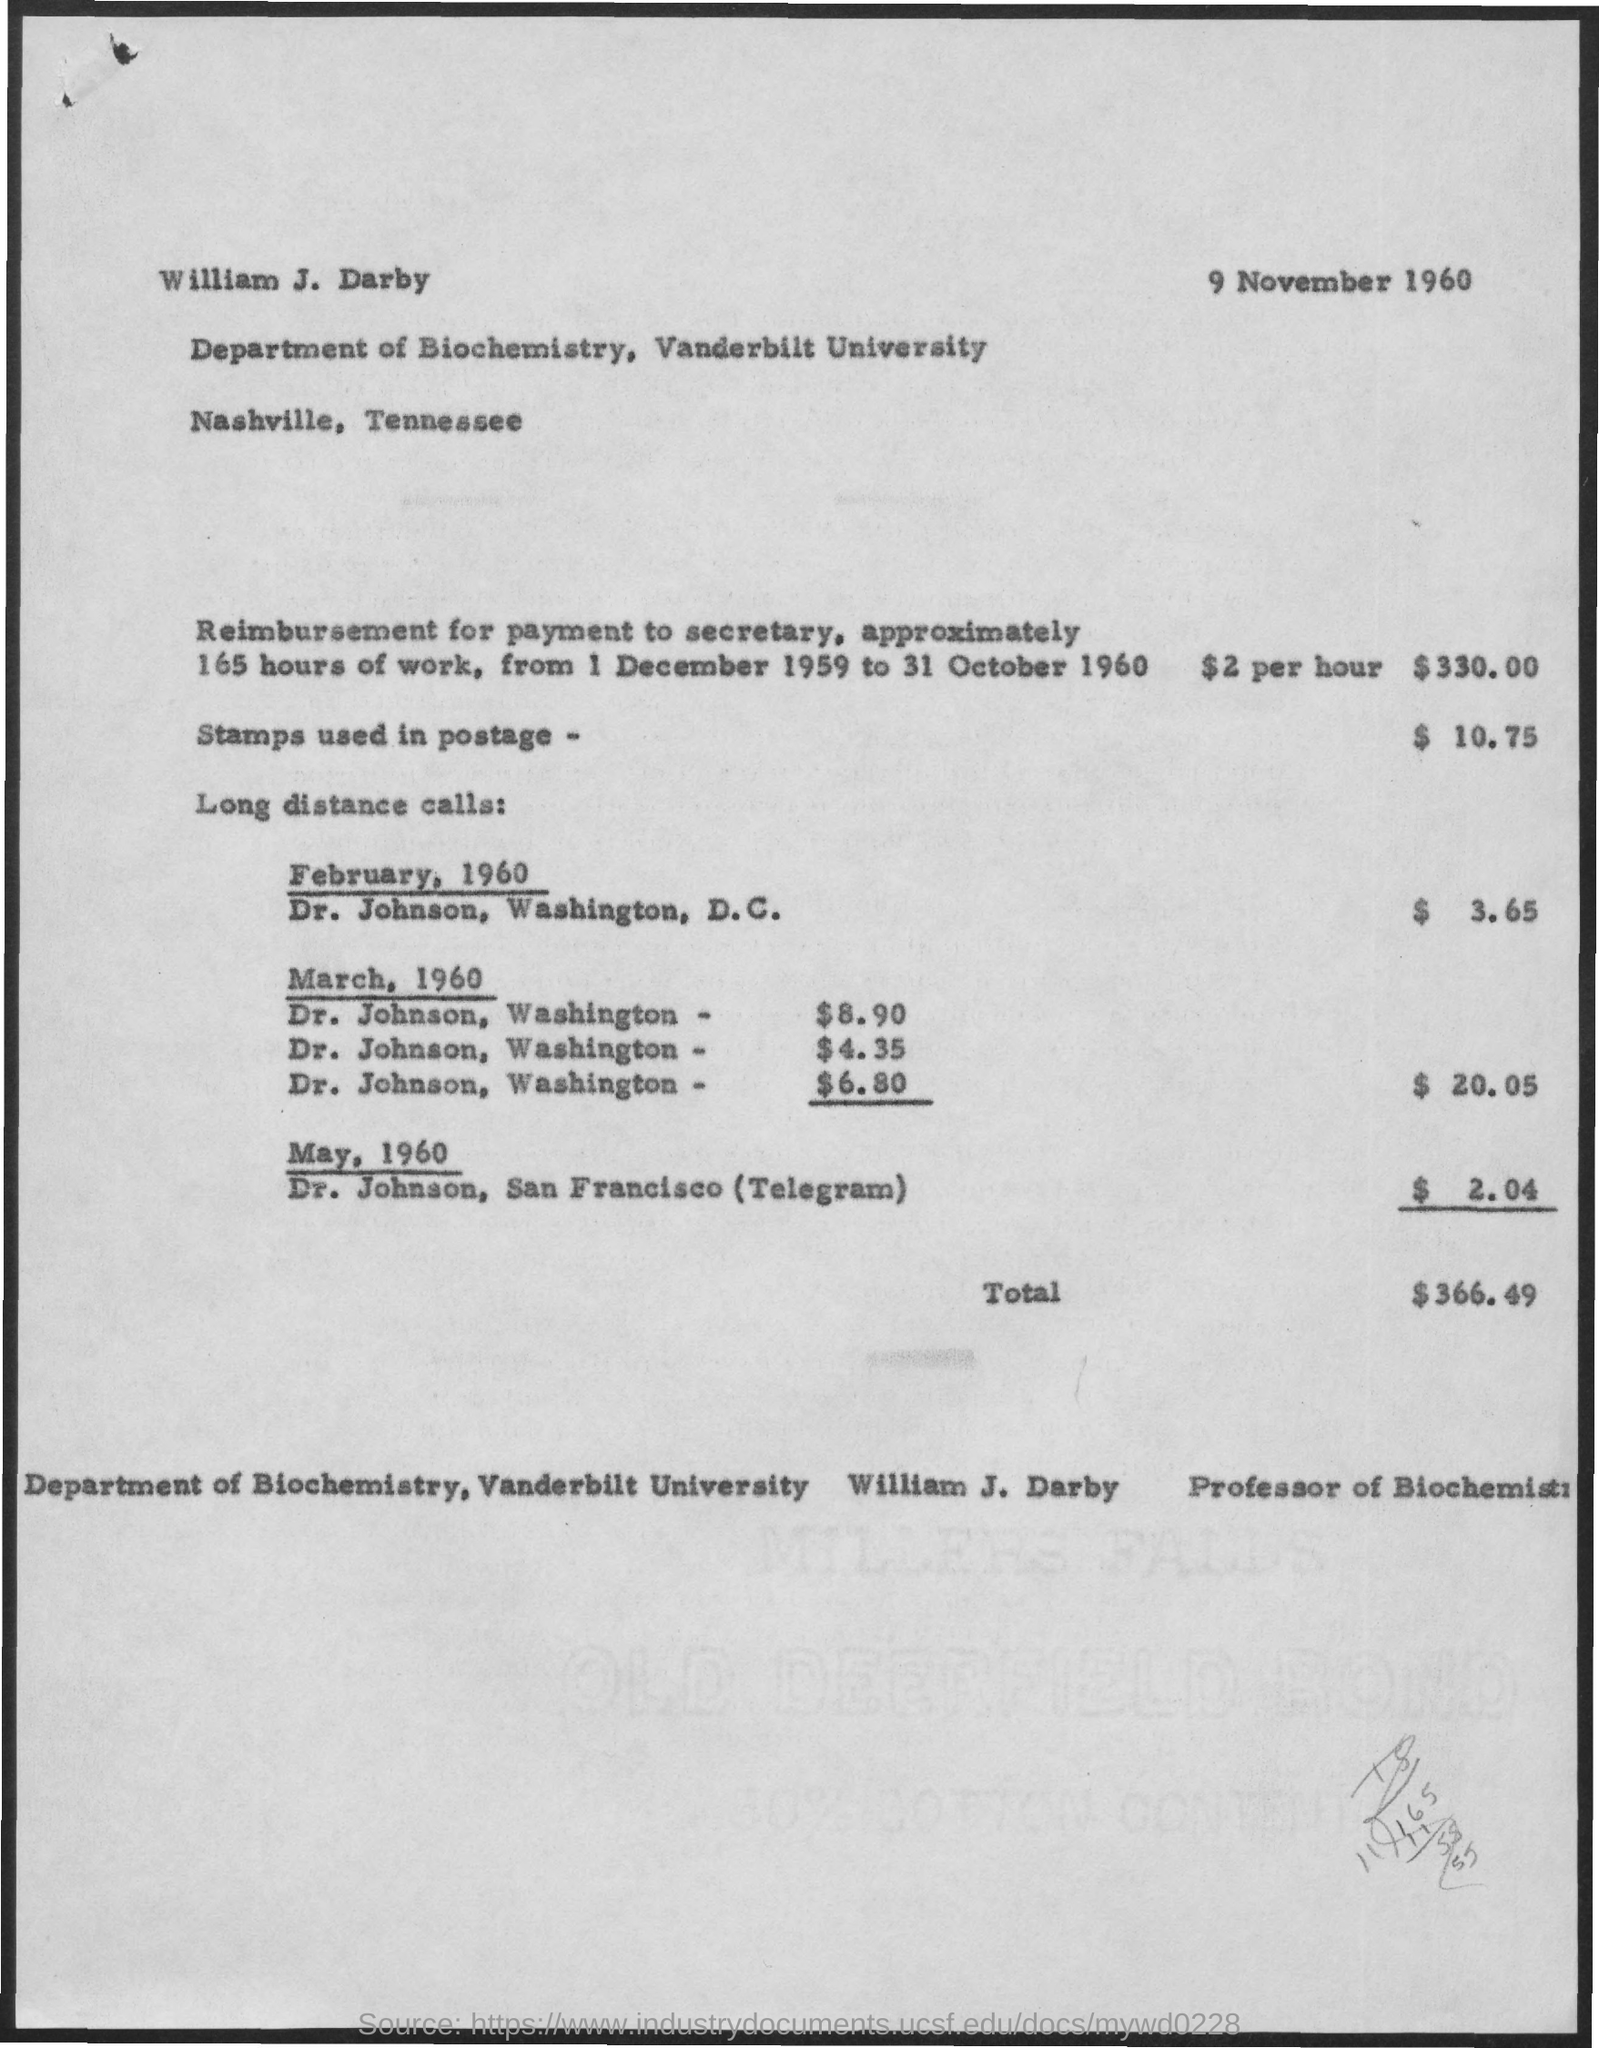What is the amount reimbursement for payment to secretary for 165 hrs of work?
Offer a terse response. $330.00. What are charges for stamps used in postage?
Provide a short and direct response. $ 10.75. What are charges for long distance calls on february, 1960?
Provide a short and direct response. $3.65. What are charges in total for long distance calls on march, 1960?
Keep it short and to the point. $20.05. What are charges for telegram to sanfrancisco on may, 1960?
Offer a very short reply. $2.04. What is total amount ?
Provide a succinct answer. $366.49. What is the date and year mentioned at top of the page?
Make the answer very short. 9 november 1960. 